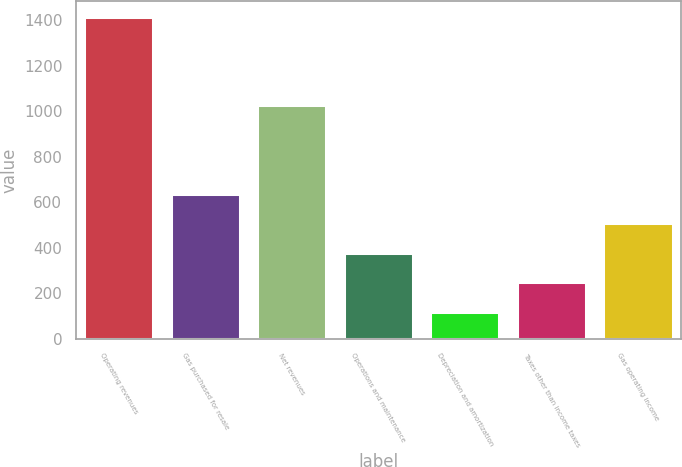Convert chart to OTSL. <chart><loc_0><loc_0><loc_500><loc_500><bar_chart><fcel>Operating revenues<fcel>Gas purchased for resale<fcel>Net revenues<fcel>Operations and maintenance<fcel>Depreciation and amortization<fcel>Taxes other than income taxes<fcel>Gas operating income<nl><fcel>1415<fcel>638<fcel>1028<fcel>379<fcel>120<fcel>249.5<fcel>508.5<nl></chart> 